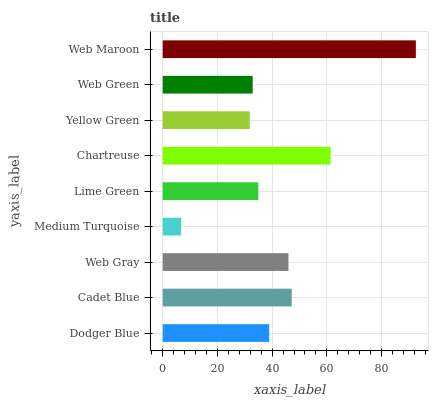Is Medium Turquoise the minimum?
Answer yes or no. Yes. Is Web Maroon the maximum?
Answer yes or no. Yes. Is Cadet Blue the minimum?
Answer yes or no. No. Is Cadet Blue the maximum?
Answer yes or no. No. Is Cadet Blue greater than Dodger Blue?
Answer yes or no. Yes. Is Dodger Blue less than Cadet Blue?
Answer yes or no. Yes. Is Dodger Blue greater than Cadet Blue?
Answer yes or no. No. Is Cadet Blue less than Dodger Blue?
Answer yes or no. No. Is Dodger Blue the high median?
Answer yes or no. Yes. Is Dodger Blue the low median?
Answer yes or no. Yes. Is Web Maroon the high median?
Answer yes or no. No. Is Web Gray the low median?
Answer yes or no. No. 